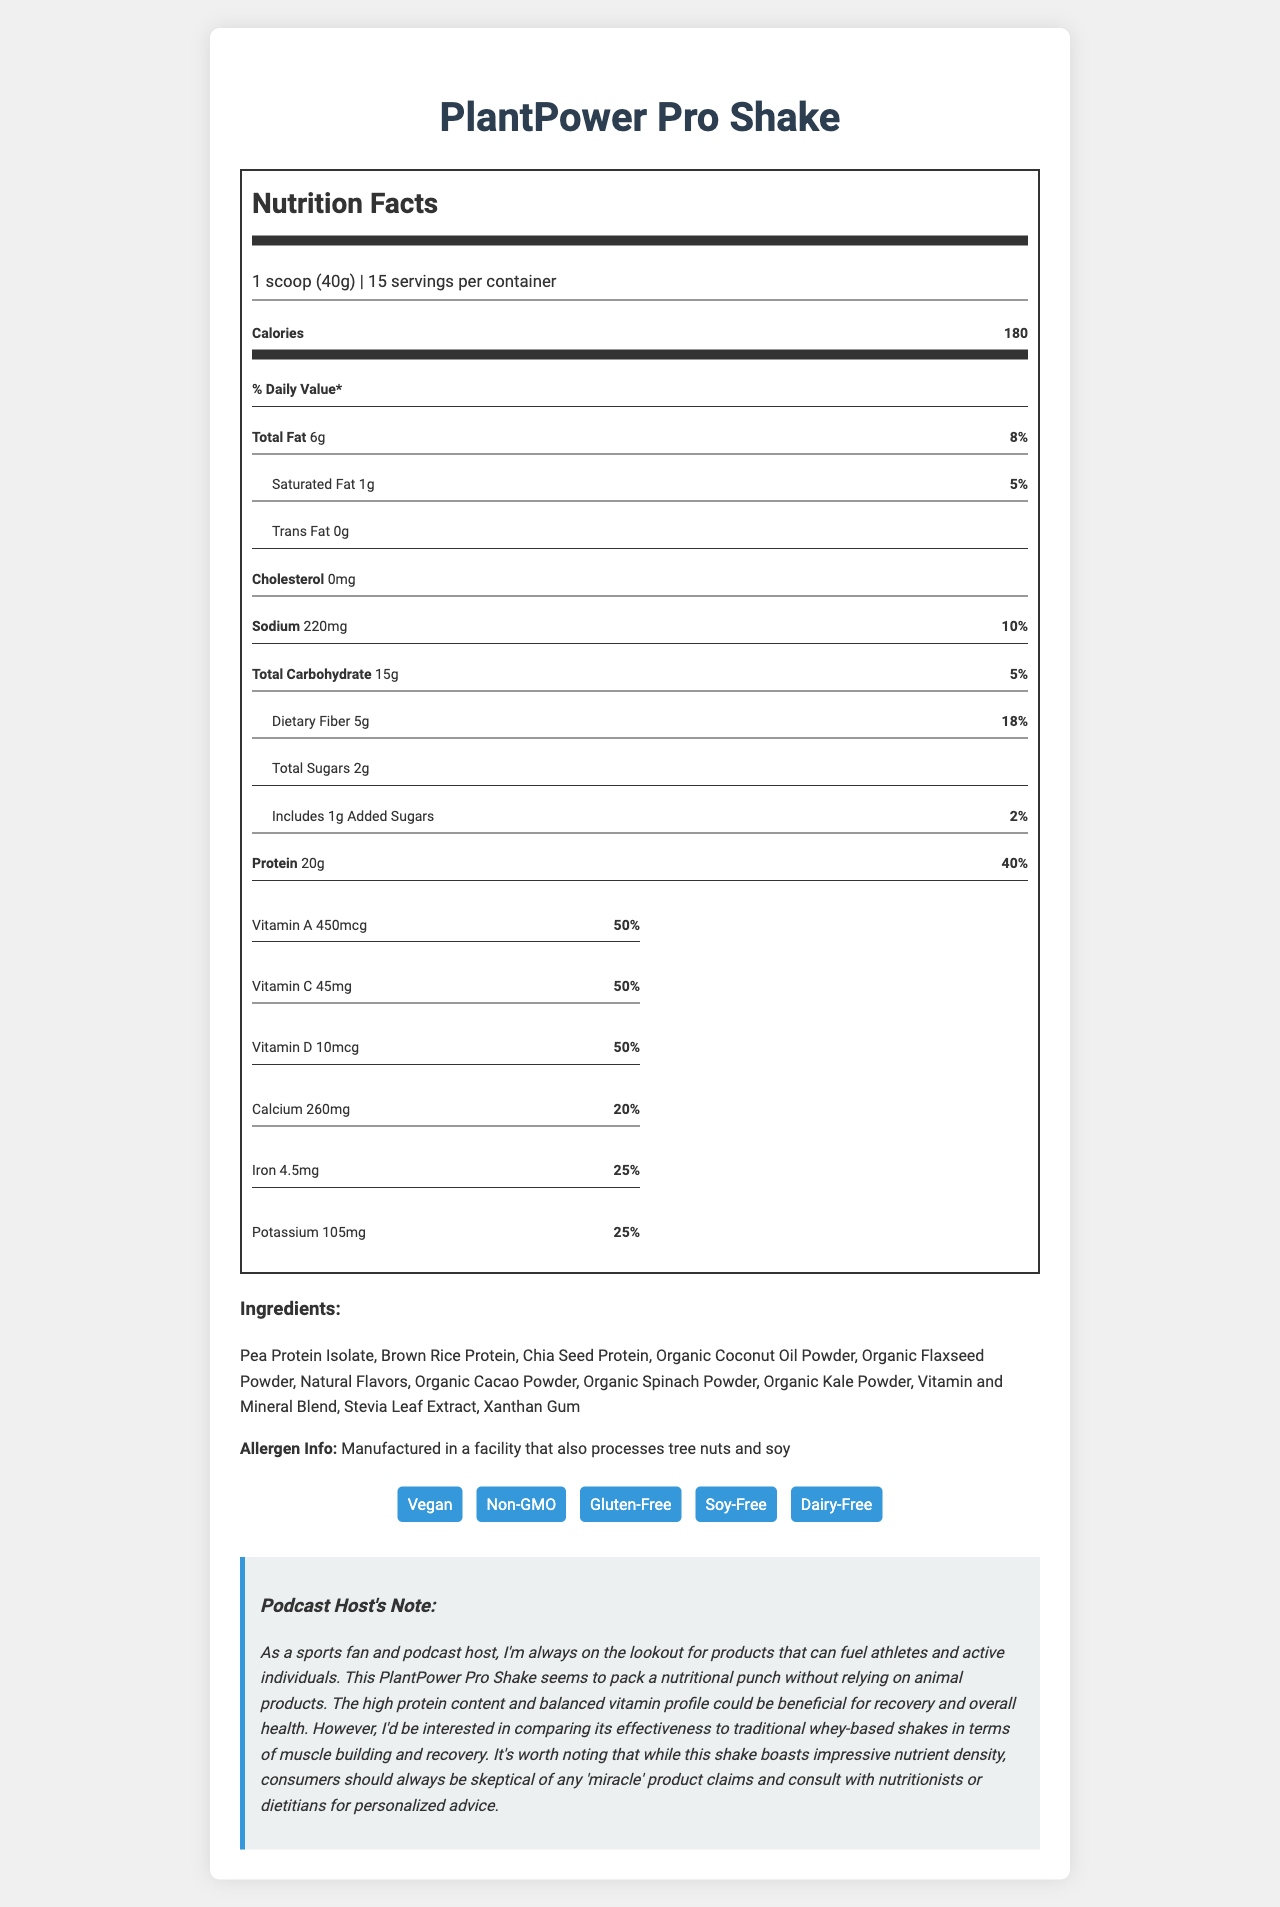what is the serving size for PlantPower Pro Shake? The document lists the serving size as "1 scoop (40g)" at the beginning of the nutrition label.
Answer: 1 scoop (40g) how many servings are there per container? The document mentions that each container has "15 servings".
Answer: 15 servings how many grams of protein are in one serving? The protein content is shown as "20g" per serving in the nutrition facts section.
Answer: 20g what percentage of the daily value of dietary fiber does one serving provide? The document states that one serving provides "18%" of the daily value for dietary fiber.
Answer: 18% does this product contain any cholesterol? The document indicates that the product contains "0mg" of cholesterol, which means it's cholesterol-free.
Answer: No what type of dietary lifestyle is this product suitable for? A. Vegan B. Keto C. Paleo D. Gluten-Free The product has labels indicating it is both "Vegan" and "Gluten-Free."
Answer: A and D which vitamin has the highest daily value percentage in one serving? A. Vitamin A B. Vitamin C C. Vitamin D D. Vitamin E All four vitamins (A, C, D, and E) have an equal daily value percentage of 50%.
Answer: A, B, C, and D is there any added sugar in this product? The nutrition facts label shows that the product includes "1g" of added sugars with a daily value percentage of “2%”.
Answer: Yes does this product contain any soy? The document specifies that the product is "Soy-Free" in the lifestyle labels section.
Answer: No summarize the main idea of the document. The document comprehensively summarizes the nutritional content, ingredient list, lifestyle labels, and additional comments from the podcast host, making it a useful resource for understanding the benefits and potential considerations of the PlantPower Pro Shake.
Answer: The document provides detailed nutritional information about the PlantPower Pro Shake, including serving size, calories, fats, carbohydrates, protein, vitamins, and minerals. It also lists ingredients, allergen information, and lifestyle labels. The product is designed to be a nutrient-dense, plant-based meal replacement that is suitable for various dietary restrictions. The podcast host note highlights the potential benefits for athletes and active individuals but advises caution and consultation with nutrition professionals. what are the main protein sources in this shake? These are listed as the first three ingredients, indicating they are the primary sources of protein.
Answer: Pea Protein Isolate, Brown Rice Protein, Chia Seed Protein what percentage of the daily value of calcium does one serving contain? The document lists calcium content as 260mg, which is 20% of the daily value.
Answer: 20% which ingredient in the shake might be a concern for someone with tree nut allergies? The allergen info section specifies that the product is made in a facility that processes tree nuts, which could be a concern for those with allergies.
Answer: The shake is manufactured in a facility that also processes tree nuts. how does the document suggest the effectiveness of this plant-based shake compares to traditional whey-based shakes in terms of muscle recovery? The document includes a note from the podcast host expressing interest in comparing the effectiveness but does not provide data or conclusions, making it impossible to determine based on the information given.
Answer: I don't know what is the amount of sodium in one serving and its daily value percentage? The document lists sodium content as 220mg, which is 10% of the daily value.
Answer: 220mg, 10% how much total carbohydrate is in one serving? The nutrition facts section shows that there are 15g of total carbohydrates per serving.
Answer: 15g what features of the product make it suitable for vegans? The product uses plant-based ingredients and includes a "Vegan" label in the lifestyle labels section.
Answer: Plant-based ingredients, Vegan label what type of flavors are used in this shake? The ingredient list includes "Natural Flavors", indicating these are used in the product.
Answer: Natural Flavors how much iron does one serving contain? A. 2mg B. 4.5mg C. 6mg D. 10mg The document shows that one serving contains "4.5mg" of iron, which is 25% of the daily value.
Answer: B 